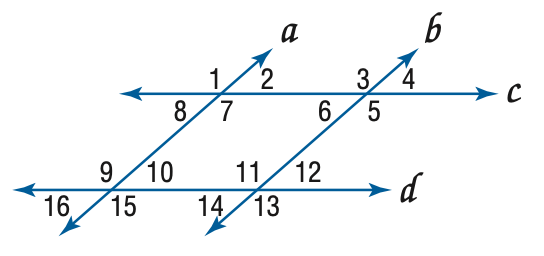Answer the mathemtical geometry problem and directly provide the correct option letter.
Question: In the figure, a \parallel b, c \parallel d, and m \angle 4 = 57. Find the measure of \angle 1.
Choices: A: 57 B: 113 C: 123 D: 133 C 